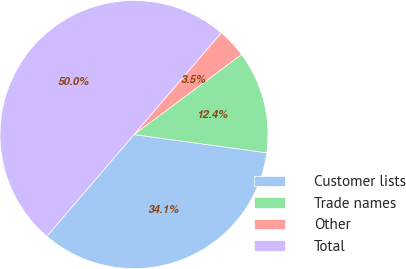Convert chart to OTSL. <chart><loc_0><loc_0><loc_500><loc_500><pie_chart><fcel>Customer lists<fcel>Trade names<fcel>Other<fcel>Total<nl><fcel>34.1%<fcel>12.36%<fcel>3.54%<fcel>50.0%<nl></chart> 